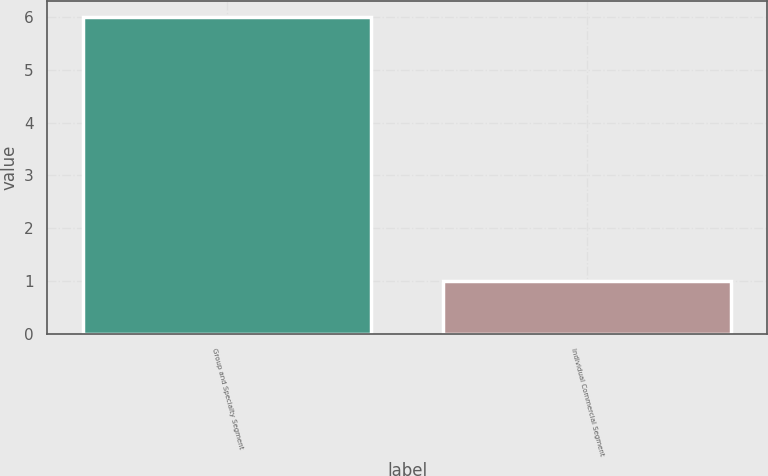<chart> <loc_0><loc_0><loc_500><loc_500><bar_chart><fcel>Group and Specialty Segment<fcel>Individual Commercial Segment<nl><fcel>6<fcel>1<nl></chart> 